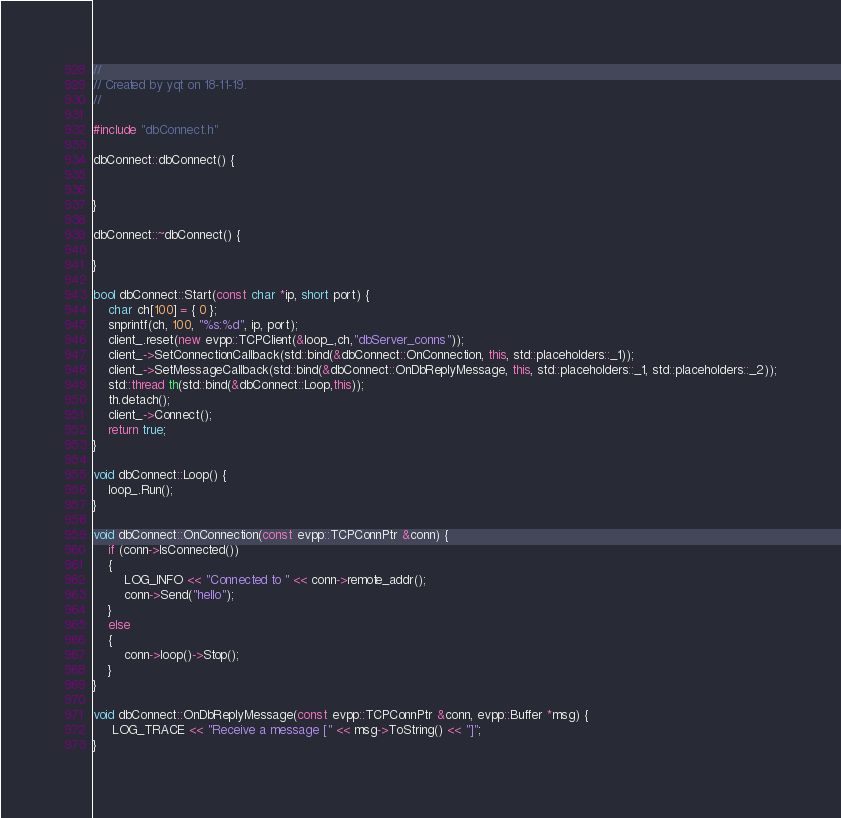<code> <loc_0><loc_0><loc_500><loc_500><_C++_>//
// Created by yqt on 18-11-19.
//

#include "dbConnect.h"

dbConnect::dbConnect() {


}

dbConnect::~dbConnect() {

}

bool dbConnect::Start(const char *ip, short port) {
    char ch[100] = { 0 };
    snprintf(ch, 100, "%s:%d", ip, port);
    client_.reset(new evpp::TCPClient(&loop_,ch,"dbServer_conns"));
    client_->SetConnectionCallback(std::bind(&dbConnect::OnConnection, this, std::placeholders::_1));
	client_->SetMessageCallback(std::bind(&dbConnect::OnDbReplyMessage, this, std::placeholders::_1, std::placeholders::_2));
    std::thread th(std::bind(&dbConnect::Loop,this));
    th.detach();
    client_->Connect();
    return true;
}

void dbConnect::Loop() {
    loop_.Run();
}

void dbConnect::OnConnection(const evpp::TCPConnPtr &conn) {
    if (conn->IsConnected())
    {
        LOG_INFO << "Connected to " << conn->remote_addr();
        conn->Send("hello");
    }
    else
    {
        conn->loop()->Stop();
    }
}

void dbConnect::OnDbReplyMessage(const evpp::TCPConnPtr &conn, evpp::Buffer *msg) {
     LOG_TRACE << "Receive a message [" << msg->ToString() << "]";
}
</code> 